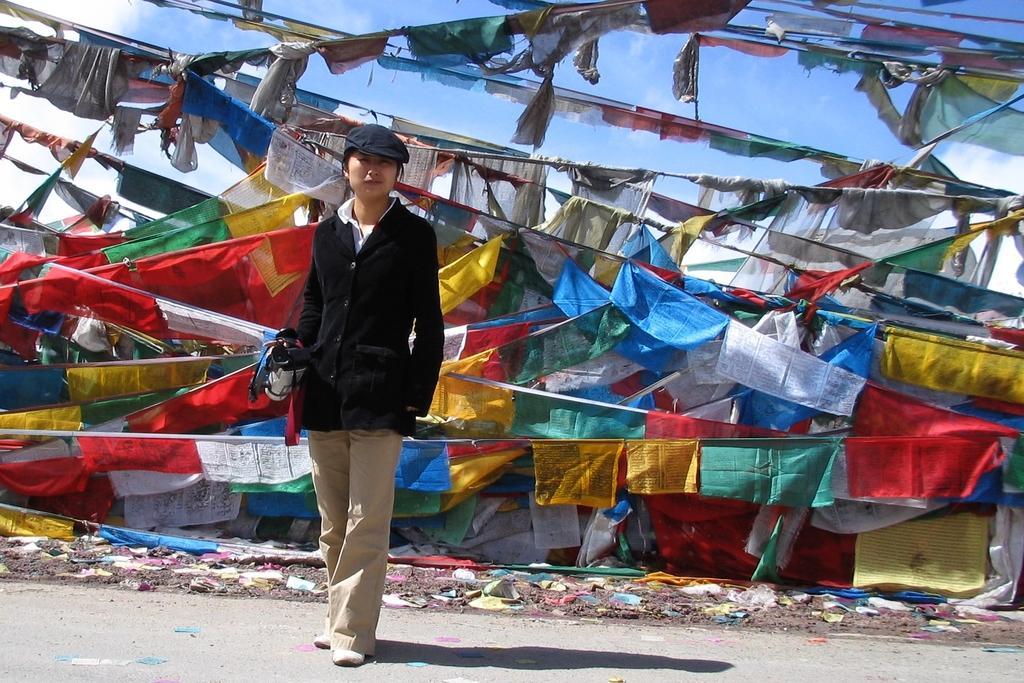Could you give a brief overview of what you see in this image? There is one woman standing and wearing a black color coat and holding an object in the middle of this image. There are some clothes hanging the background. There is a sky at the top of this image. 